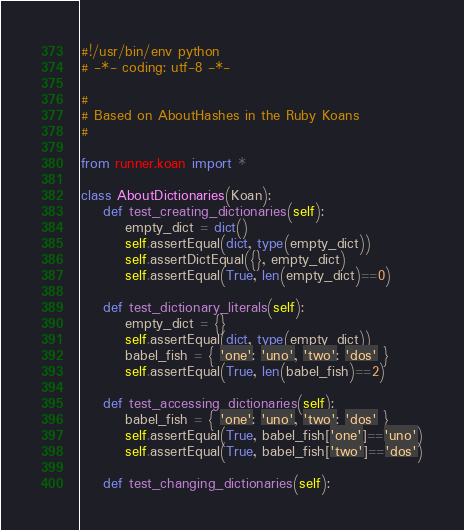<code> <loc_0><loc_0><loc_500><loc_500><_Python_>#!/usr/bin/env python
# -*- coding: utf-8 -*-

#
# Based on AboutHashes in the Ruby Koans
#

from runner.koan import *

class AboutDictionaries(Koan):
    def test_creating_dictionaries(self):
        empty_dict = dict()
        self.assertEqual(dict, type(empty_dict))
        self.assertDictEqual({}, empty_dict)
        self.assertEqual(True, len(empty_dict)==0)

    def test_dictionary_literals(self):
        empty_dict = {}
        self.assertEqual(dict, type(empty_dict))
        babel_fish = { 'one': 'uno', 'two': 'dos' }
        self.assertEqual(True, len(babel_fish)==2)

    def test_accessing_dictionaries(self):
        babel_fish = { 'one': 'uno', 'two': 'dos' }
        self.assertEqual(True, babel_fish['one']=='uno')
        self.assertEqual(True, babel_fish['two']=='dos')

    def test_changing_dictionaries(self):</code> 